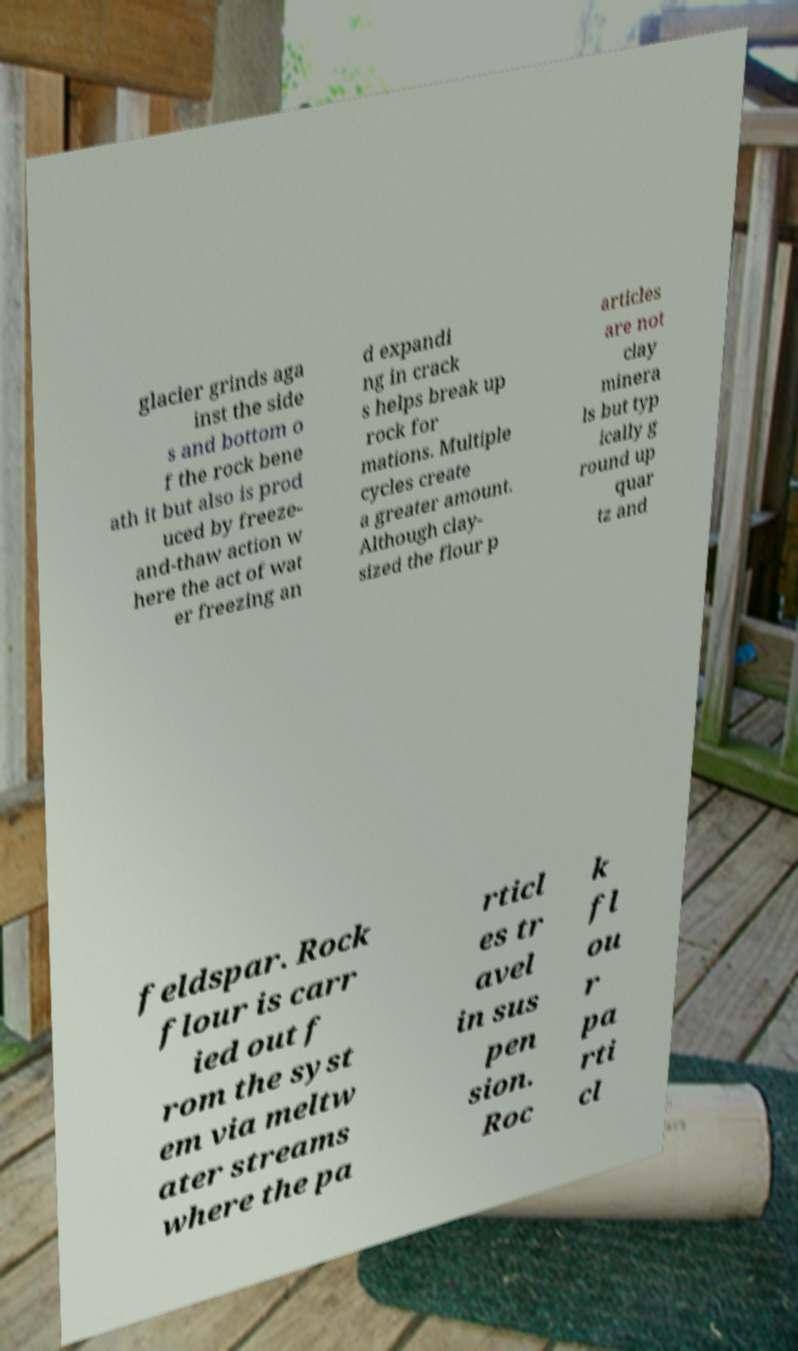What messages or text are displayed in this image? I need them in a readable, typed format. glacier grinds aga inst the side s and bottom o f the rock bene ath it but also is prod uced by freeze- and-thaw action w here the act of wat er freezing an d expandi ng in crack s helps break up rock for mations. Multiple cycles create a greater amount. Although clay- sized the flour p articles are not clay minera ls but typ ically g round up quar tz and feldspar. Rock flour is carr ied out f rom the syst em via meltw ater streams where the pa rticl es tr avel in sus pen sion. Roc k fl ou r pa rti cl 